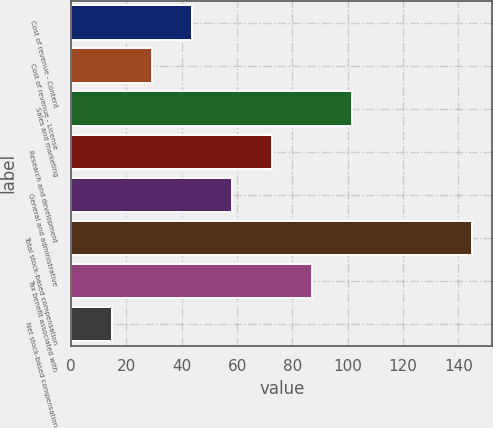<chart> <loc_0><loc_0><loc_500><loc_500><bar_chart><fcel>Cost of revenue - Content<fcel>Cost of revenue - License<fcel>Sales and marketing<fcel>Research and development<fcel>General and administrative<fcel>Total stock-based compensation<fcel>Tax benefit associated with<fcel>Net stock-based compensation<nl><fcel>43.6<fcel>29.11<fcel>101.56<fcel>72.58<fcel>58.09<fcel>145<fcel>87.07<fcel>14.62<nl></chart> 